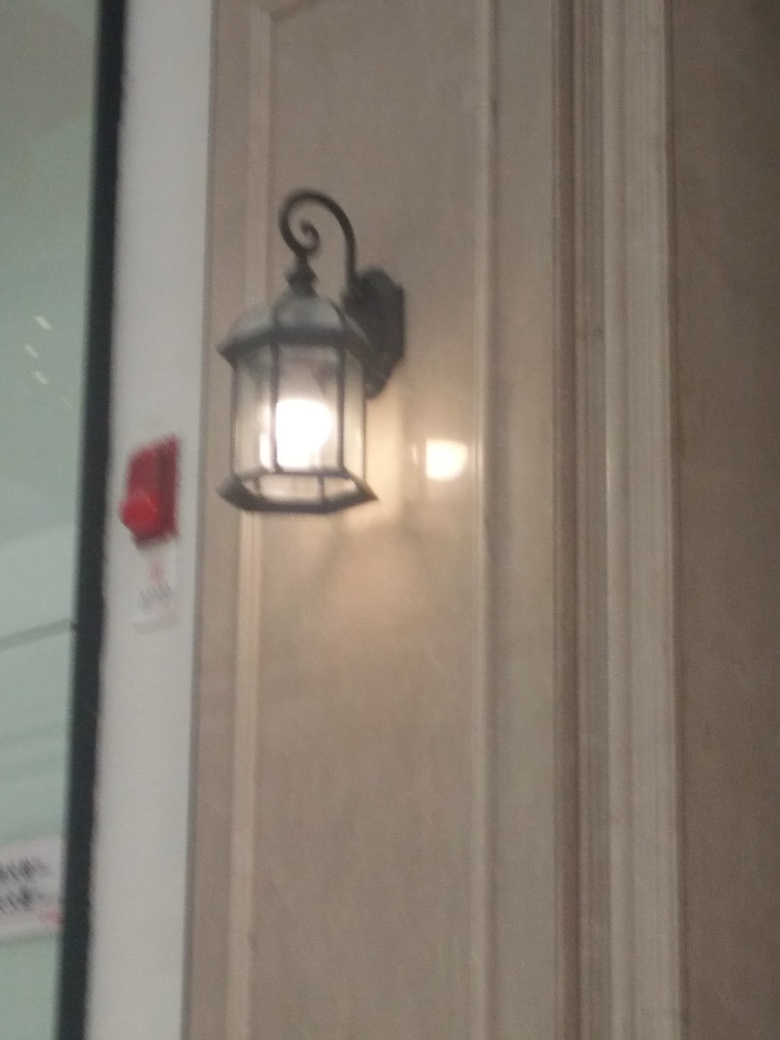Are there any quality issues with this image? Yes, the image appears to be blurred, which affects the sharpness and clarity of the details. The lighting conditions seem to be uneven, with a strong reflection causing glare on the right side. Additionally, the angle of the shot could be improved to give a clearer view of the lamp and its surroundings. 